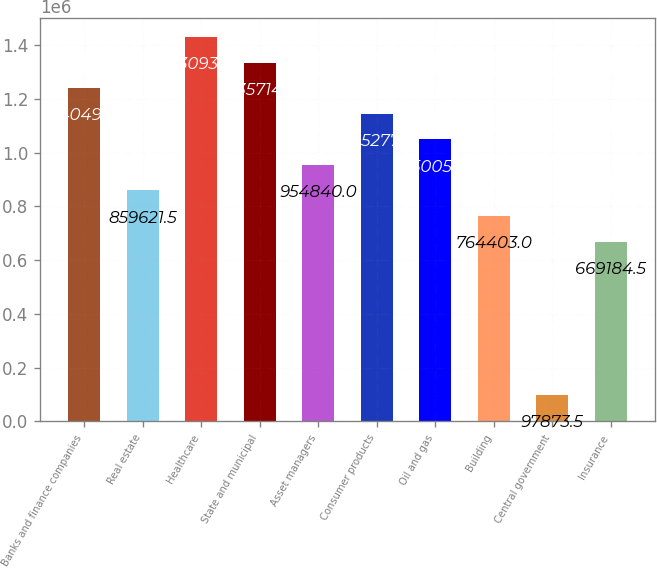Convert chart to OTSL. <chart><loc_0><loc_0><loc_500><loc_500><bar_chart><fcel>Banks and finance companies<fcel>Real estate<fcel>Healthcare<fcel>State and municipal<fcel>Asset managers<fcel>Consumer products<fcel>Oil and gas<fcel>Building<fcel>Central government<fcel>Insurance<nl><fcel>1.2405e+06<fcel>859622<fcel>1.43093e+06<fcel>1.33571e+06<fcel>954840<fcel>1.14528e+06<fcel>1.05006e+06<fcel>764403<fcel>97873.5<fcel>669184<nl></chart> 